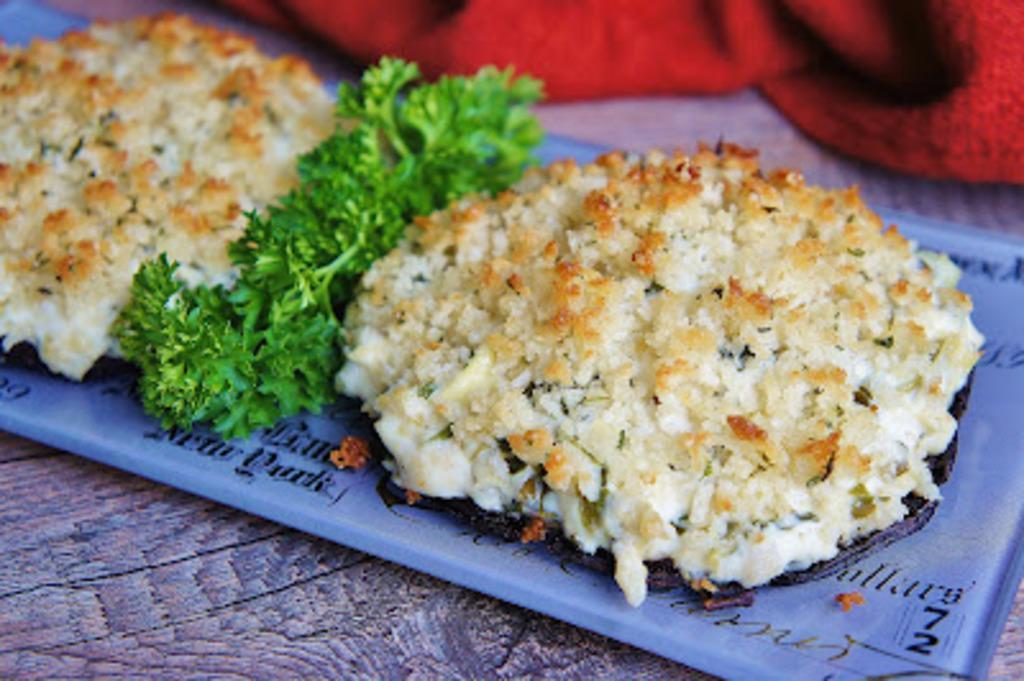In one or two sentences, can you explain what this image depicts? In this picture, we can see some food items served in a plate kept on the wooden surface, and we can see some red color object on the top side of the picture. 